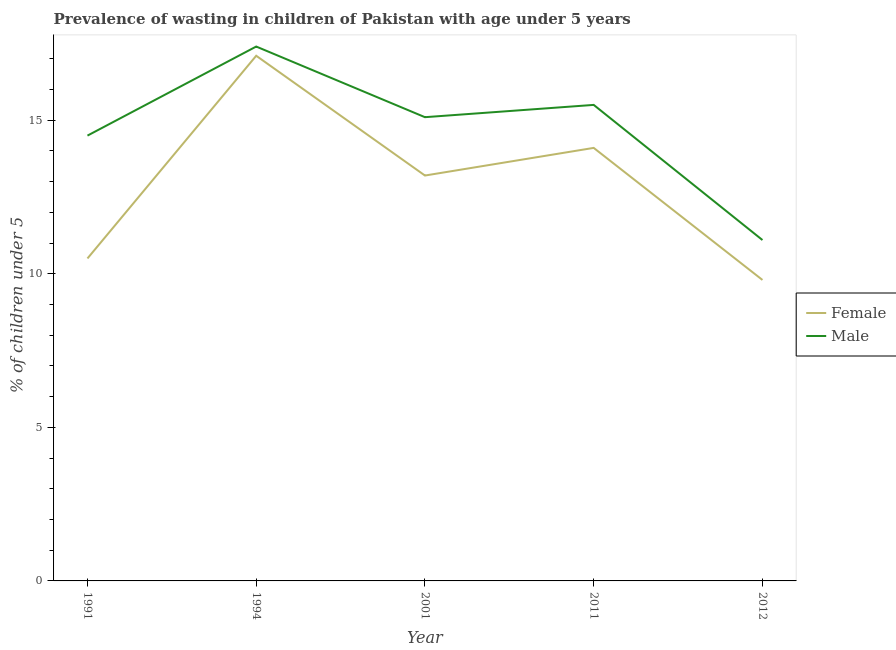Is the number of lines equal to the number of legend labels?
Make the answer very short. Yes. What is the percentage of undernourished female children in 1994?
Give a very brief answer. 17.1. Across all years, what is the maximum percentage of undernourished female children?
Keep it short and to the point. 17.1. Across all years, what is the minimum percentage of undernourished male children?
Provide a succinct answer. 11.1. What is the total percentage of undernourished male children in the graph?
Your answer should be compact. 73.6. What is the difference between the percentage of undernourished male children in 2011 and that in 2012?
Your answer should be compact. 4.4. What is the difference between the percentage of undernourished male children in 2011 and the percentage of undernourished female children in 2001?
Provide a short and direct response. 2.3. What is the average percentage of undernourished female children per year?
Offer a very short reply. 12.94. In the year 2011, what is the difference between the percentage of undernourished female children and percentage of undernourished male children?
Your answer should be compact. -1.4. In how many years, is the percentage of undernourished male children greater than 16 %?
Give a very brief answer. 1. What is the ratio of the percentage of undernourished male children in 2011 to that in 2012?
Ensure brevity in your answer.  1.4. Is the difference between the percentage of undernourished female children in 1991 and 1994 greater than the difference between the percentage of undernourished male children in 1991 and 1994?
Your response must be concise. No. What is the difference between the highest and the second highest percentage of undernourished male children?
Ensure brevity in your answer.  1.9. What is the difference between the highest and the lowest percentage of undernourished male children?
Give a very brief answer. 6.3. Is the percentage of undernourished female children strictly less than the percentage of undernourished male children over the years?
Keep it short and to the point. Yes. Are the values on the major ticks of Y-axis written in scientific E-notation?
Provide a short and direct response. No. Does the graph contain grids?
Offer a terse response. No. How are the legend labels stacked?
Offer a very short reply. Vertical. What is the title of the graph?
Ensure brevity in your answer.  Prevalence of wasting in children of Pakistan with age under 5 years. What is the label or title of the Y-axis?
Your response must be concise.  % of children under 5. What is the  % of children under 5 of Female in 1991?
Offer a very short reply. 10.5. What is the  % of children under 5 of Male in 1991?
Offer a very short reply. 14.5. What is the  % of children under 5 of Female in 1994?
Offer a very short reply. 17.1. What is the  % of children under 5 in Male in 1994?
Offer a terse response. 17.4. What is the  % of children under 5 of Female in 2001?
Your answer should be very brief. 13.2. What is the  % of children under 5 in Male in 2001?
Your answer should be very brief. 15.1. What is the  % of children under 5 of Female in 2011?
Provide a succinct answer. 14.1. What is the  % of children under 5 in Male in 2011?
Your response must be concise. 15.5. What is the  % of children under 5 in Female in 2012?
Your answer should be compact. 9.8. What is the  % of children under 5 of Male in 2012?
Your response must be concise. 11.1. Across all years, what is the maximum  % of children under 5 of Female?
Keep it short and to the point. 17.1. Across all years, what is the maximum  % of children under 5 in Male?
Keep it short and to the point. 17.4. Across all years, what is the minimum  % of children under 5 in Female?
Your response must be concise. 9.8. Across all years, what is the minimum  % of children under 5 of Male?
Make the answer very short. 11.1. What is the total  % of children under 5 of Female in the graph?
Keep it short and to the point. 64.7. What is the total  % of children under 5 in Male in the graph?
Your answer should be compact. 73.6. What is the difference between the  % of children under 5 of Female in 1991 and that in 1994?
Offer a very short reply. -6.6. What is the difference between the  % of children under 5 of Male in 1991 and that in 1994?
Provide a succinct answer. -2.9. What is the difference between the  % of children under 5 of Female in 1991 and that in 2011?
Offer a very short reply. -3.6. What is the difference between the  % of children under 5 in Male in 1991 and that in 2012?
Offer a terse response. 3.4. What is the difference between the  % of children under 5 of Female in 1994 and that in 2001?
Give a very brief answer. 3.9. What is the difference between the  % of children under 5 in Male in 1994 and that in 2001?
Keep it short and to the point. 2.3. What is the difference between the  % of children under 5 of Female in 1994 and that in 2011?
Give a very brief answer. 3. What is the difference between the  % of children under 5 of Male in 1994 and that in 2012?
Offer a terse response. 6.3. What is the difference between the  % of children under 5 in Male in 2001 and that in 2011?
Make the answer very short. -0.4. What is the difference between the  % of children under 5 of Male in 2001 and that in 2012?
Ensure brevity in your answer.  4. What is the difference between the  % of children under 5 in Male in 2011 and that in 2012?
Your answer should be compact. 4.4. What is the difference between the  % of children under 5 of Female in 1994 and the  % of children under 5 of Male in 2001?
Your answer should be very brief. 2. What is the difference between the  % of children under 5 in Female in 1994 and the  % of children under 5 in Male in 2011?
Offer a terse response. 1.6. What is the difference between the  % of children under 5 of Female in 2001 and the  % of children under 5 of Male in 2012?
Provide a short and direct response. 2.1. What is the difference between the  % of children under 5 of Female in 2011 and the  % of children under 5 of Male in 2012?
Your answer should be compact. 3. What is the average  % of children under 5 in Female per year?
Your answer should be very brief. 12.94. What is the average  % of children under 5 of Male per year?
Offer a very short reply. 14.72. In the year 1991, what is the difference between the  % of children under 5 in Female and  % of children under 5 in Male?
Give a very brief answer. -4. In the year 2001, what is the difference between the  % of children under 5 of Female and  % of children under 5 of Male?
Make the answer very short. -1.9. In the year 2012, what is the difference between the  % of children under 5 of Female and  % of children under 5 of Male?
Make the answer very short. -1.3. What is the ratio of the  % of children under 5 of Female in 1991 to that in 1994?
Your answer should be compact. 0.61. What is the ratio of the  % of children under 5 in Male in 1991 to that in 1994?
Keep it short and to the point. 0.83. What is the ratio of the  % of children under 5 of Female in 1991 to that in 2001?
Give a very brief answer. 0.8. What is the ratio of the  % of children under 5 in Male in 1991 to that in 2001?
Make the answer very short. 0.96. What is the ratio of the  % of children under 5 in Female in 1991 to that in 2011?
Your answer should be compact. 0.74. What is the ratio of the  % of children under 5 of Male in 1991 to that in 2011?
Give a very brief answer. 0.94. What is the ratio of the  % of children under 5 in Female in 1991 to that in 2012?
Offer a terse response. 1.07. What is the ratio of the  % of children under 5 in Male in 1991 to that in 2012?
Your response must be concise. 1.31. What is the ratio of the  % of children under 5 in Female in 1994 to that in 2001?
Make the answer very short. 1.3. What is the ratio of the  % of children under 5 of Male in 1994 to that in 2001?
Your response must be concise. 1.15. What is the ratio of the  % of children under 5 of Female in 1994 to that in 2011?
Keep it short and to the point. 1.21. What is the ratio of the  % of children under 5 of Male in 1994 to that in 2011?
Your answer should be very brief. 1.12. What is the ratio of the  % of children under 5 in Female in 1994 to that in 2012?
Provide a succinct answer. 1.74. What is the ratio of the  % of children under 5 of Male in 1994 to that in 2012?
Give a very brief answer. 1.57. What is the ratio of the  % of children under 5 in Female in 2001 to that in 2011?
Keep it short and to the point. 0.94. What is the ratio of the  % of children under 5 of Male in 2001 to that in 2011?
Ensure brevity in your answer.  0.97. What is the ratio of the  % of children under 5 of Female in 2001 to that in 2012?
Provide a succinct answer. 1.35. What is the ratio of the  % of children under 5 in Male in 2001 to that in 2012?
Offer a terse response. 1.36. What is the ratio of the  % of children under 5 in Female in 2011 to that in 2012?
Provide a short and direct response. 1.44. What is the ratio of the  % of children under 5 of Male in 2011 to that in 2012?
Provide a succinct answer. 1.4. What is the difference between the highest and the second highest  % of children under 5 of Male?
Ensure brevity in your answer.  1.9. What is the difference between the highest and the lowest  % of children under 5 of Female?
Make the answer very short. 7.3. 